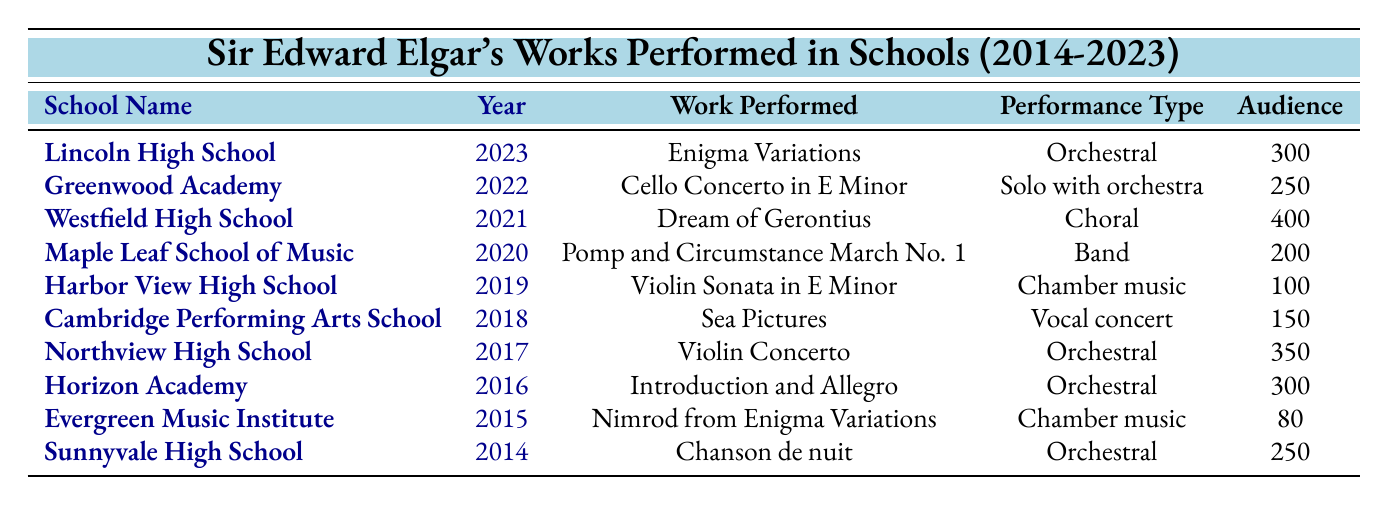What is the work performed at Lincoln High School in 2023? The table states that the work performed at Lincoln High School in 2023 is the "Enigma Variations."
Answer: Enigma Variations Which school had the largest audience for a performance? By comparing the audience sizes listed, Westfield High School had the largest audience with 400 people for the performance of "Dream of Gerontius."
Answer: Westfield High School How many orchestral performances were reported in the table? Counting the "Performance Type" entries labeled as "Orchestral" (3 total), those are Lincoln High School, Northview High School, and Horizon Academy.
Answer: 3 What year did Cambridge Performing Arts School perform "Sea Pictures"? The table indicates that "Sea Pictures" was performed by Cambridge Performing Arts School in 2018.
Answer: 2018 Which performance types were showcased more than once in the table? The performance types "Orchestral" and "Chamber music" appeared multiple times (Orchestral: 4, Chamber music: 2).
Answer: Orchestral and Chamber music How many students were in the ensemble for the performance at Harbor View High School? According to the table, the ensemble size for the performance at Harbor View High School was 6.
Answer: 6 What is the average audience size of all the performances? To find the average, sum the audience sizes (300 + 250 + 400 + 200 + 100 + 150 + 350 + 300 + 80 + 250 = 2080) and divide by the number of performances (10), resulting in 2080 / 10 = 208.
Answer: 208 Did any school perform "Nimrod from Enigma Variations"? Yes, the Evergreen Music Institute performed "Nimrod from Enigma Variations" in 2015.
Answer: Yes What is the difference in ensemble size between the largest and smallest group? The largest ensemble size was at Westfield High School with 60 members and the smallest was at Evergreen Music Institute with 8 members. The difference is 60 - 8 = 52.
Answer: 52 Which performance had an audience size of 80? The performance with an audience size of 80 was "Nimrod from Enigma Variations" performed by Evergreen Music Institute.
Answer: Nimrod from Enigma Variations 